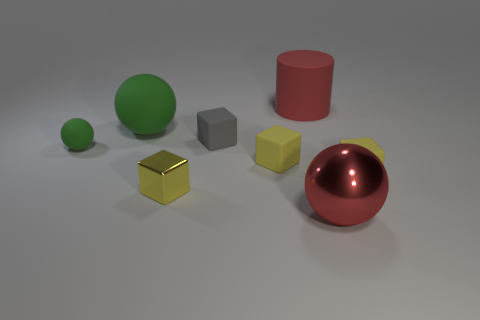What's the lighting like in the scene? The lighting in the scene is soft and diffused, coming from above. There aren't any harsh shadows or bright highlights, which creates a calm and even ambience throughout the image. Is there any object that seems out of place compared to the others? Not particularly, all objects seem to share a similar minimalist style and are likely there to showcase various geometric forms and textures. However, the golden cube could be considered unique due to its metallic finish which stands out against the matte textures of the other items. 